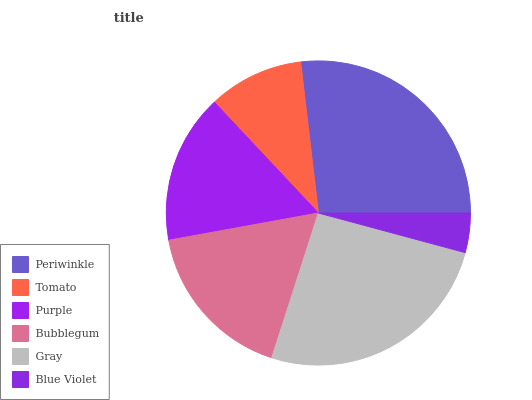Is Blue Violet the minimum?
Answer yes or no. Yes. Is Periwinkle the maximum?
Answer yes or no. Yes. Is Tomato the minimum?
Answer yes or no. No. Is Tomato the maximum?
Answer yes or no. No. Is Periwinkle greater than Tomato?
Answer yes or no. Yes. Is Tomato less than Periwinkle?
Answer yes or no. Yes. Is Tomato greater than Periwinkle?
Answer yes or no. No. Is Periwinkle less than Tomato?
Answer yes or no. No. Is Bubblegum the high median?
Answer yes or no. Yes. Is Purple the low median?
Answer yes or no. Yes. Is Tomato the high median?
Answer yes or no. No. Is Bubblegum the low median?
Answer yes or no. No. 